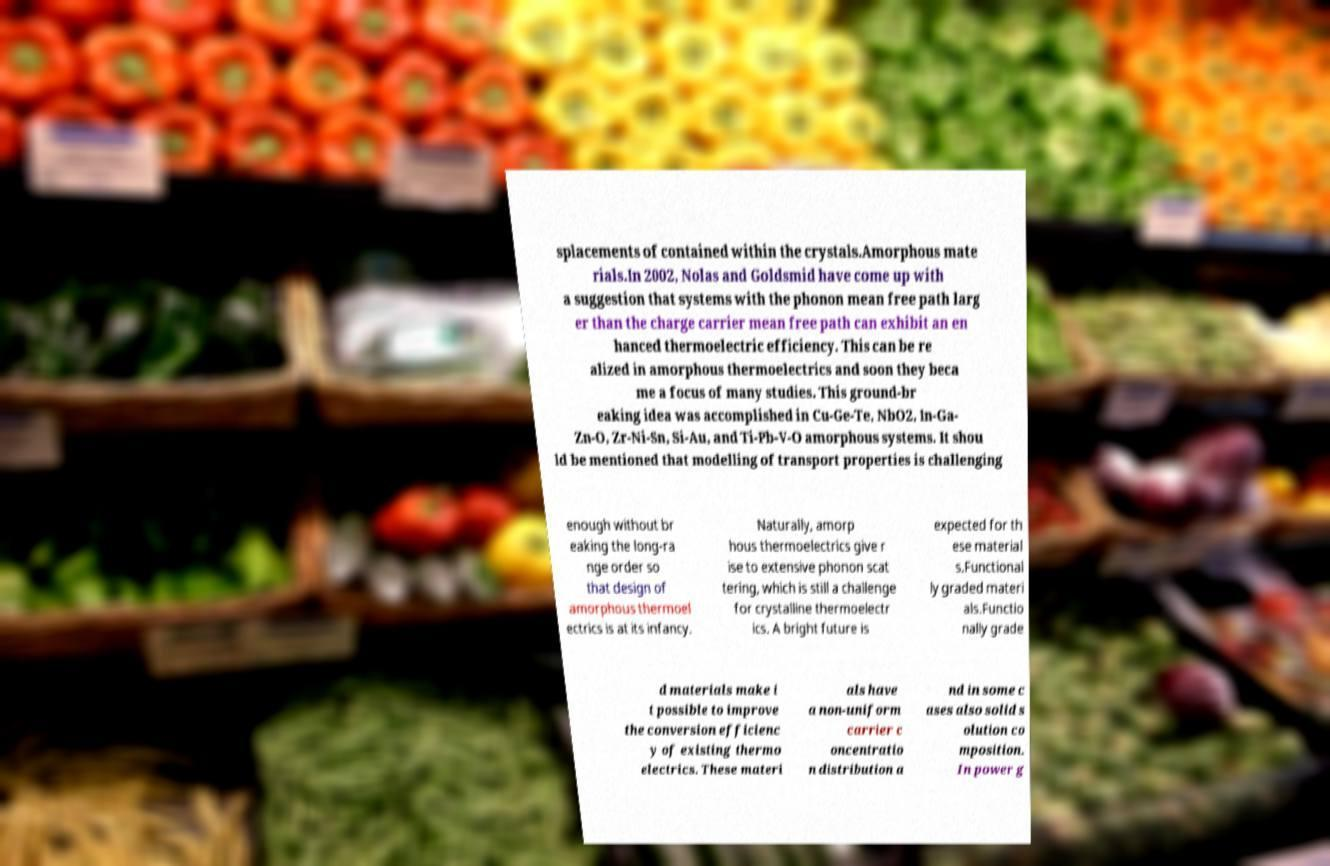I need the written content from this picture converted into text. Can you do that? splacements of contained within the crystals.Amorphous mate rials.In 2002, Nolas and Goldsmid have come up with a suggestion that systems with the phonon mean free path larg er than the charge carrier mean free path can exhibit an en hanced thermoelectric efficiency. This can be re alized in amorphous thermoelectrics and soon they beca me a focus of many studies. This ground-br eaking idea was accomplished in Cu-Ge-Te, NbO2, In-Ga- Zn-O, Zr-Ni-Sn, Si-Au, and Ti-Pb-V-O amorphous systems. It shou ld be mentioned that modelling of transport properties is challenging enough without br eaking the long-ra nge order so that design of amorphous thermoel ectrics is at its infancy. Naturally, amorp hous thermoelectrics give r ise to extensive phonon scat tering, which is still a challenge for crystalline thermoelectr ics. A bright future is expected for th ese material s.Functional ly graded materi als.Functio nally grade d materials make i t possible to improve the conversion efficienc y of existing thermo electrics. These materi als have a non-uniform carrier c oncentratio n distribution a nd in some c ases also solid s olution co mposition. In power g 